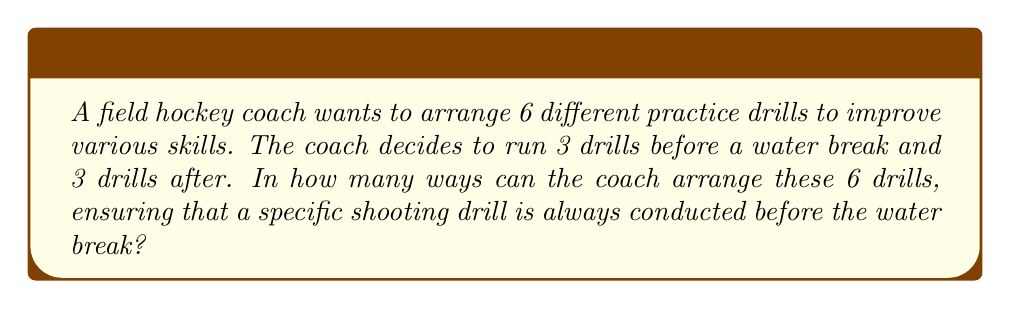Teach me how to tackle this problem. Let's approach this step-by-step:

1) First, we need to consider that one specific drill (the shooting drill) must be before the water break. This leaves us with 5 other drills to arrange.

2) We need to choose 2 more drills to go before the water break, along with the shooting drill. This can be done in $\binom{5}{2}$ ways.

   $\binom{5}{2} = \frac{5!}{2!(5-2)!} = \frac{5 \cdot 4}{2 \cdot 1} = 10$

3) Once we've chosen these 2 drills, we need to arrange them along with the shooting drill. This can be done in 3! ways.

4) The remaining 3 drills will go after the water break, and can be arranged in 3! ways as well.

5) By the multiplication principle, the total number of ways to arrange the drills is:

   $$ 10 \cdot 3! \cdot 3! = 10 \cdot 6 \cdot 6 = 360 $$

This arrangement ensures optimal skill improvement by guaranteeing that the crucial shooting drill is always practiced before the players potentially fatigue after the water break, while still allowing for variety in the overall practice structure.
Answer: 360 